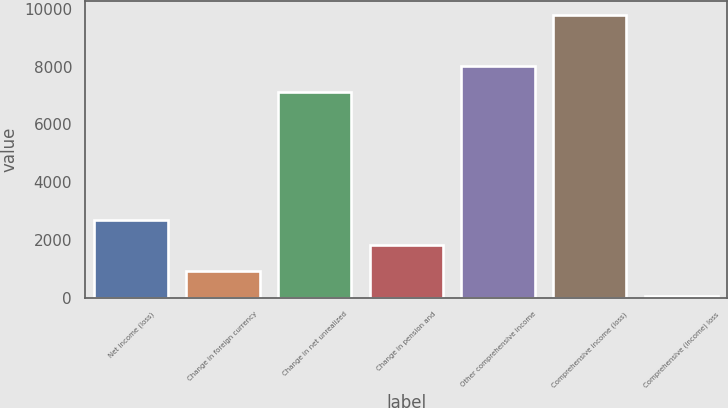<chart> <loc_0><loc_0><loc_500><loc_500><bar_chart><fcel>Net income (loss)<fcel>Change in foreign currency<fcel>Change in net unrealized<fcel>Change in pension and<fcel>Other comprehensive income<fcel>Comprehensive income (loss)<fcel>Comprehensive (income) loss<nl><fcel>2700.8<fcel>927.6<fcel>7135<fcel>1814.2<fcel>8021.6<fcel>9794.8<fcel>41<nl></chart> 